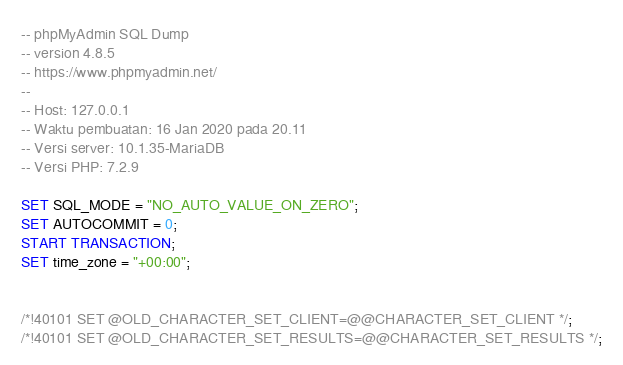<code> <loc_0><loc_0><loc_500><loc_500><_SQL_>-- phpMyAdmin SQL Dump
-- version 4.8.5
-- https://www.phpmyadmin.net/
--
-- Host: 127.0.0.1
-- Waktu pembuatan: 16 Jan 2020 pada 20.11
-- Versi server: 10.1.35-MariaDB
-- Versi PHP: 7.2.9

SET SQL_MODE = "NO_AUTO_VALUE_ON_ZERO";
SET AUTOCOMMIT = 0;
START TRANSACTION;
SET time_zone = "+00:00";


/*!40101 SET @OLD_CHARACTER_SET_CLIENT=@@CHARACTER_SET_CLIENT */;
/*!40101 SET @OLD_CHARACTER_SET_RESULTS=@@CHARACTER_SET_RESULTS */;</code> 